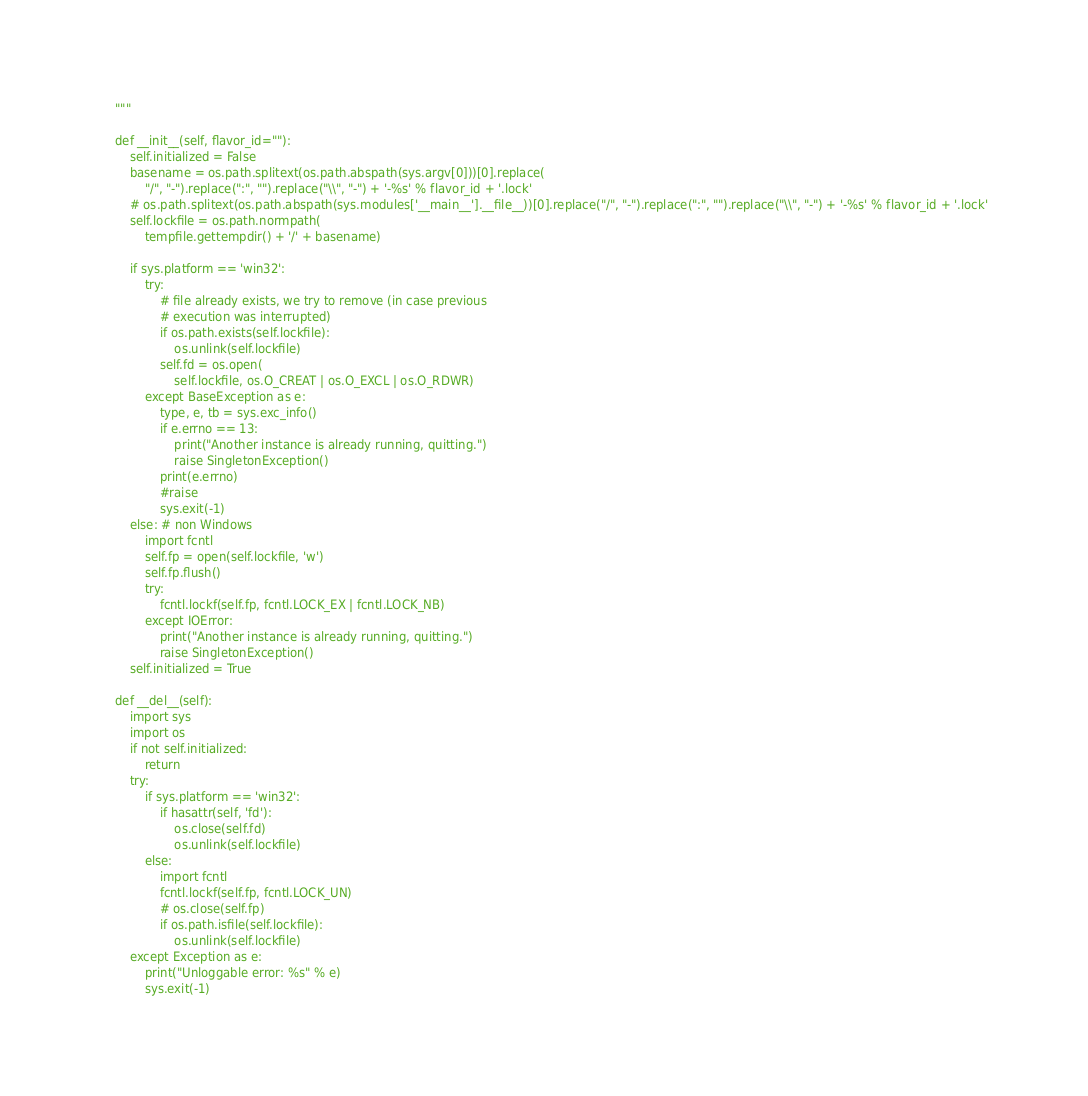<code> <loc_0><loc_0><loc_500><loc_500><_Python_>	"""

	def __init__(self, flavor_id=""):
		self.initialized = False
		basename = os.path.splitext(os.path.abspath(sys.argv[0]))[0].replace(
			"/", "-").replace(":", "").replace("\\", "-") + '-%s' % flavor_id + '.lock'
		# os.path.splitext(os.path.abspath(sys.modules['__main__'].__file__))[0].replace("/", "-").replace(":", "").replace("\\", "-") + '-%s' % flavor_id + '.lock'
		self.lockfile = os.path.normpath(
			tempfile.gettempdir() + '/' + basename)

		if sys.platform == 'win32':
			try:
				# file already exists, we try to remove (in case previous
				# execution was interrupted)
				if os.path.exists(self.lockfile):
					os.unlink(self.lockfile)
				self.fd = os.open(
					self.lockfile, os.O_CREAT | os.O_EXCL | os.O_RDWR)
			except BaseException as e:
				type, e, tb = sys.exc_info()
				if e.errno == 13:
					print("Another instance is already running, quitting.")
					raise SingletonException()
				print(e.errno)
				#raise
				sys.exit(-1)
		else: # non Windows
			import fcntl
			self.fp = open(self.lockfile, 'w')
			self.fp.flush()
			try:
				fcntl.lockf(self.fp, fcntl.LOCK_EX | fcntl.LOCK_NB)
			except IOError:
				print("Another instance is already running, quitting.")
				raise SingletonException()
		self.initialized = True

	def __del__(self):
		import sys
		import os
		if not self.initialized:
			return
		try:
			if sys.platform == 'win32':
				if hasattr(self, 'fd'):
					os.close(self.fd)
					os.unlink(self.lockfile)
			else:
				import fcntl
				fcntl.lockf(self.fp, fcntl.LOCK_UN)
				# os.close(self.fp)
				if os.path.isfile(self.lockfile):
					os.unlink(self.lockfile)
		except Exception as e:
			print("Unloggable error: %s" % e)
			sys.exit(-1)
</code> 